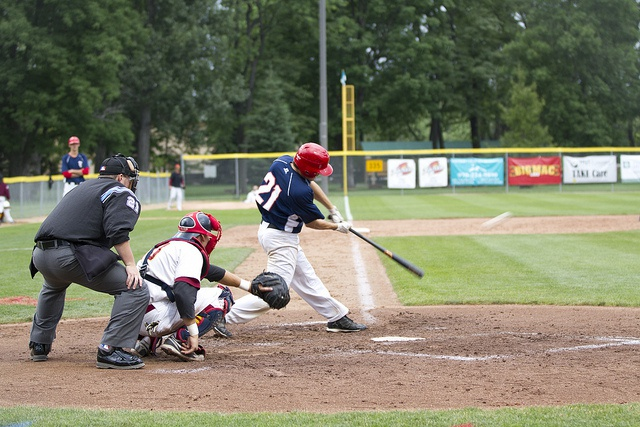Describe the objects in this image and their specific colors. I can see people in darkgreen, black, gray, and darkgray tones, people in darkgreen, lightgray, black, darkgray, and navy tones, people in darkgreen, white, black, gray, and darkgray tones, people in darkgreen, gray, lightgray, darkgray, and black tones, and baseball glove in darkgreen, black, gray, and darkgray tones in this image. 